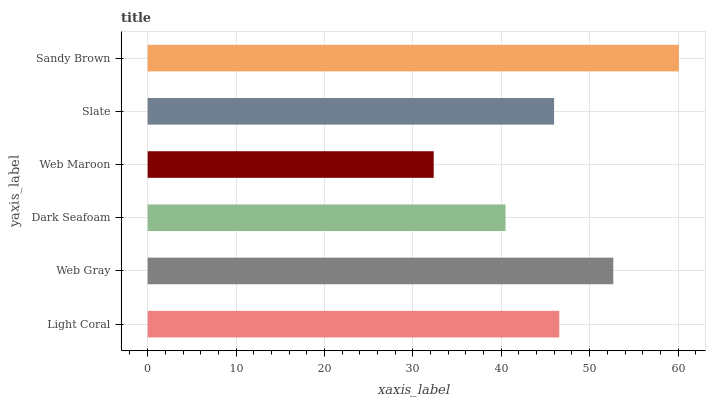Is Web Maroon the minimum?
Answer yes or no. Yes. Is Sandy Brown the maximum?
Answer yes or no. Yes. Is Web Gray the minimum?
Answer yes or no. No. Is Web Gray the maximum?
Answer yes or no. No. Is Web Gray greater than Light Coral?
Answer yes or no. Yes. Is Light Coral less than Web Gray?
Answer yes or no. Yes. Is Light Coral greater than Web Gray?
Answer yes or no. No. Is Web Gray less than Light Coral?
Answer yes or no. No. Is Light Coral the high median?
Answer yes or no. Yes. Is Slate the low median?
Answer yes or no. Yes. Is Web Maroon the high median?
Answer yes or no. No. Is Web Maroon the low median?
Answer yes or no. No. 